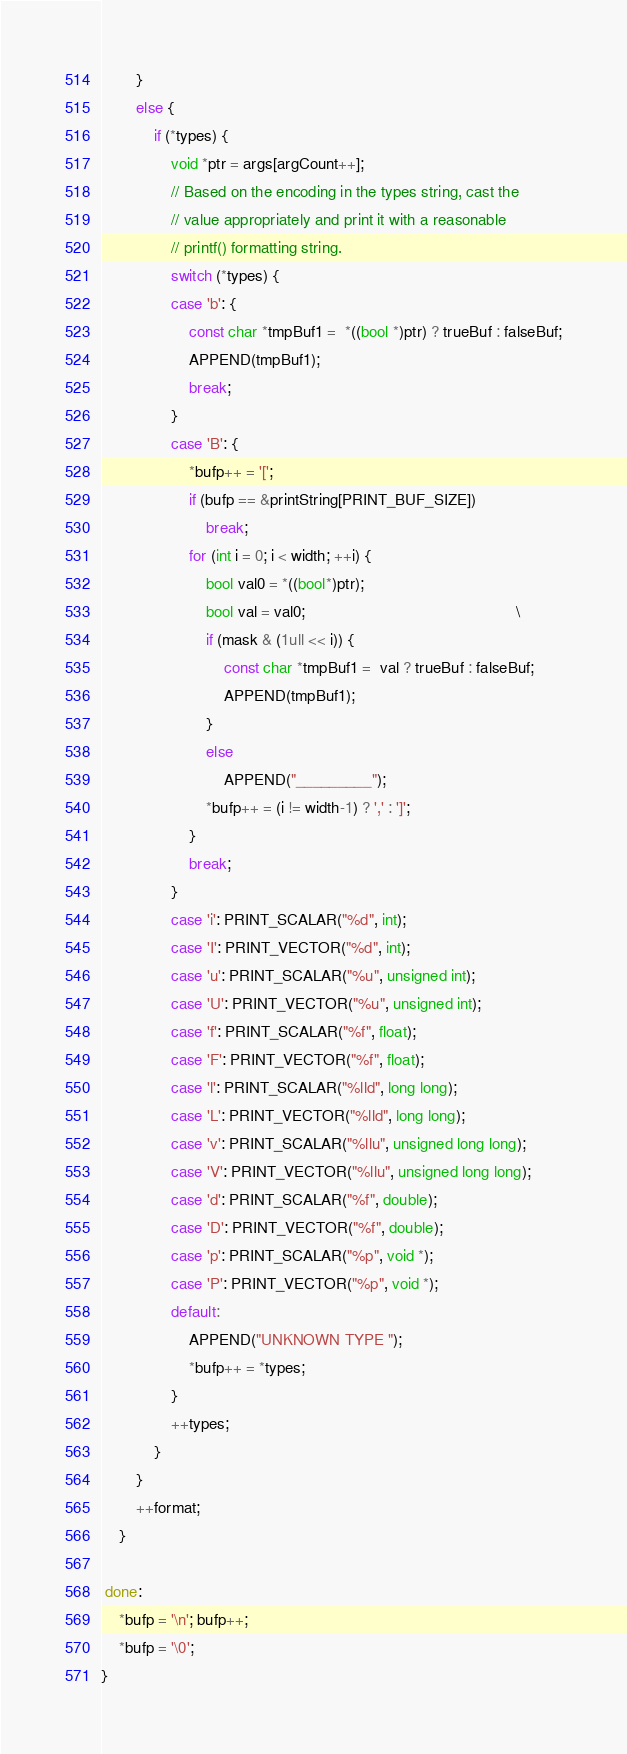<code> <loc_0><loc_0><loc_500><loc_500><_Cuda_>        }
        else {
            if (*types) {
                void *ptr = args[argCount++];
                // Based on the encoding in the types string, cast the
                // value appropriately and print it with a reasonable
                // printf() formatting string.
                switch (*types) {
                case 'b': {
                    const char *tmpBuf1 =  *((bool *)ptr) ? trueBuf : falseBuf;
                    APPEND(tmpBuf1);
                    break;
                }
                case 'B': {
                    *bufp++ = '[';
                    if (bufp == &printString[PRINT_BUF_SIZE])
                        break;
                    for (int i = 0; i < width; ++i) {
                        bool val0 = *((bool*)ptr);                                     
                        bool val = val0;                                                \
                        if (mask & (1ull << i)) {
                            const char *tmpBuf1 =  val ? trueBuf : falseBuf;
                            APPEND(tmpBuf1);
                        }
                        else
                            APPEND("_________");
                        *bufp++ = (i != width-1) ? ',' : ']';
                    }
                    break;
                }
                case 'i': PRINT_SCALAR("%d", int);
                case 'I': PRINT_VECTOR("%d", int);
                case 'u': PRINT_SCALAR("%u", unsigned int);
                case 'U': PRINT_VECTOR("%u", unsigned int);
                case 'f': PRINT_SCALAR("%f", float);
                case 'F': PRINT_VECTOR("%f", float);
                case 'l': PRINT_SCALAR("%lld", long long);
                case 'L': PRINT_VECTOR("%lld", long long);
                case 'v': PRINT_SCALAR("%llu", unsigned long long);
                case 'V': PRINT_VECTOR("%llu", unsigned long long);
                case 'd': PRINT_SCALAR("%f", double);
                case 'D': PRINT_VECTOR("%f", double);
                case 'p': PRINT_SCALAR("%p", void *);
                case 'P': PRINT_VECTOR("%p", void *);
                default:
                    APPEND("UNKNOWN TYPE ");
                    *bufp++ = *types;
                }
                ++types;
            }
        }
        ++format;
    }

 done:
    *bufp = '\n'; bufp++;
    *bufp = '\0';
}
</code> 